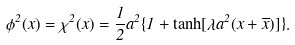Convert formula to latex. <formula><loc_0><loc_0><loc_500><loc_500>\phi ^ { 2 } ( x ) = \chi ^ { 2 } ( x ) = \frac { 1 } { 2 } a ^ { 2 } \{ 1 + \tanh [ \lambda a ^ { 2 } ( x + \overline { x } ) ] \} .</formula> 